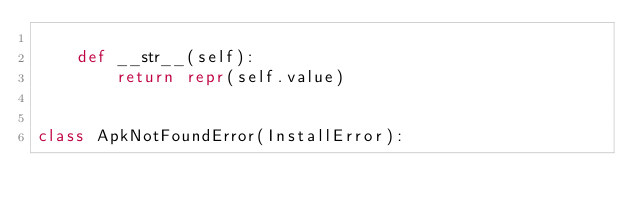Convert code to text. <code><loc_0><loc_0><loc_500><loc_500><_Python_>
    def __str__(self):
        return repr(self.value)


class ApkNotFoundError(InstallError):</code> 